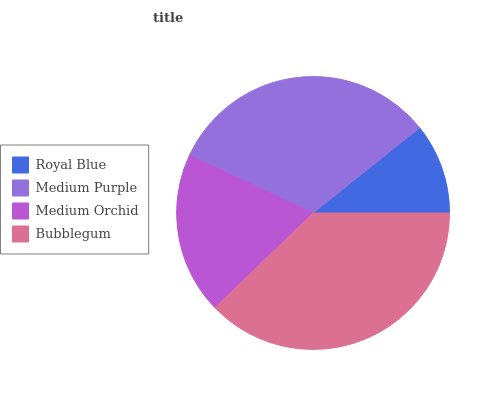Is Royal Blue the minimum?
Answer yes or no. Yes. Is Bubblegum the maximum?
Answer yes or no. Yes. Is Medium Purple the minimum?
Answer yes or no. No. Is Medium Purple the maximum?
Answer yes or no. No. Is Medium Purple greater than Royal Blue?
Answer yes or no. Yes. Is Royal Blue less than Medium Purple?
Answer yes or no. Yes. Is Royal Blue greater than Medium Purple?
Answer yes or no. No. Is Medium Purple less than Royal Blue?
Answer yes or no. No. Is Medium Purple the high median?
Answer yes or no. Yes. Is Medium Orchid the low median?
Answer yes or no. Yes. Is Medium Orchid the high median?
Answer yes or no. No. Is Medium Purple the low median?
Answer yes or no. No. 